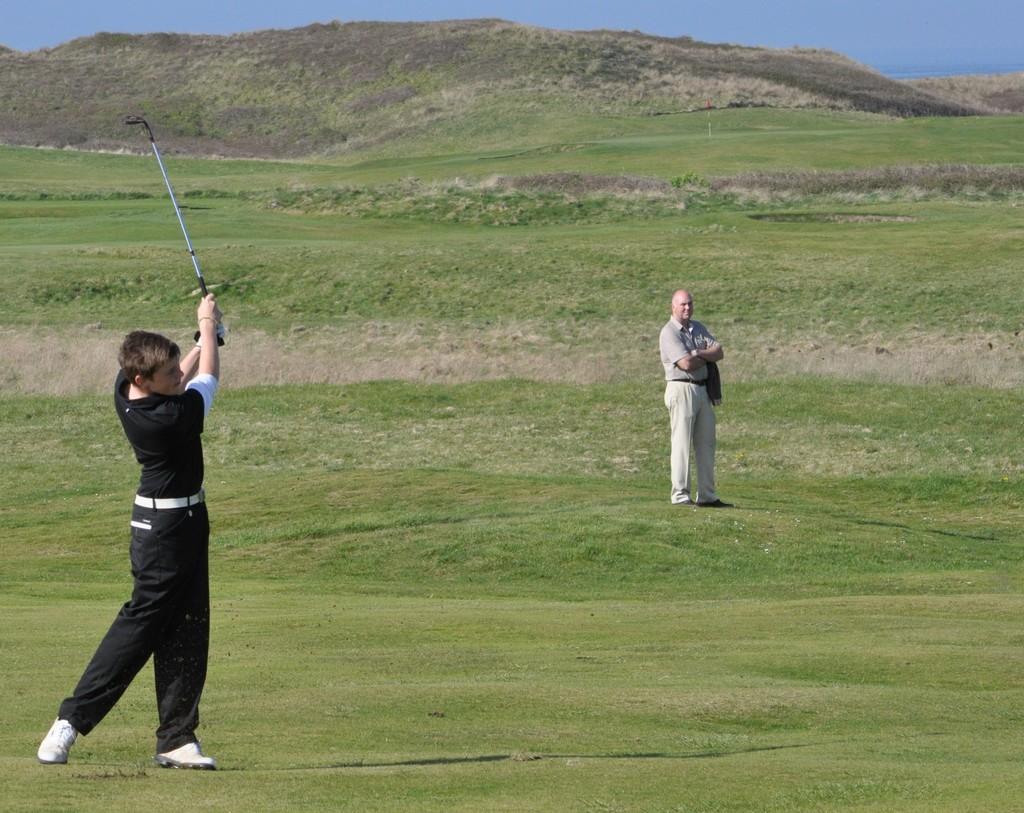In one or two sentences, can you explain what this image depicts? In this image, on the left side we can see a person holding golf bat and on the right side we can see a person standing on the grass, in the background we can see many grass and the sky. 